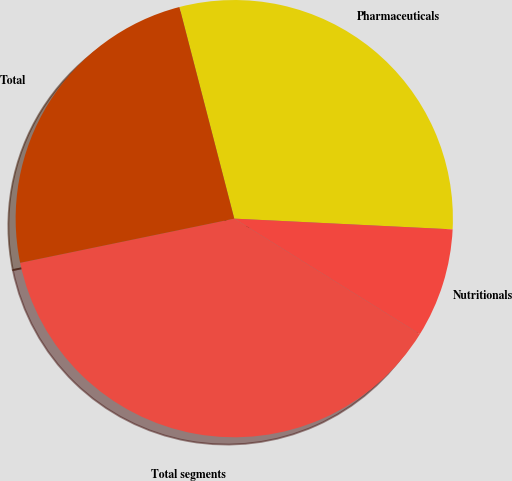Convert chart to OTSL. <chart><loc_0><loc_0><loc_500><loc_500><pie_chart><fcel>Pharmaceuticals<fcel>Nutritionals<fcel>Total segments<fcel>Total<nl><fcel>29.82%<fcel>8.08%<fcel>37.9%<fcel>24.2%<nl></chart> 